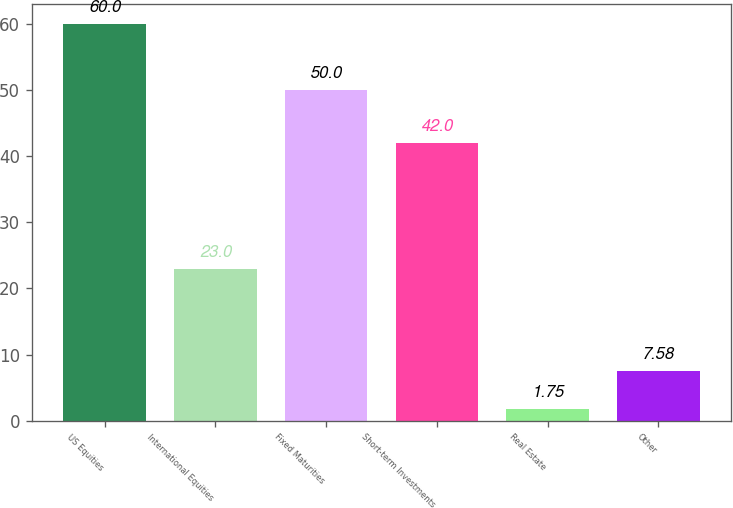Convert chart to OTSL. <chart><loc_0><loc_0><loc_500><loc_500><bar_chart><fcel>US Equities<fcel>International Equities<fcel>Fixed Maturities<fcel>Short-term Investments<fcel>Real Estate<fcel>Other<nl><fcel>60<fcel>23<fcel>50<fcel>42<fcel>1.75<fcel>7.58<nl></chart> 